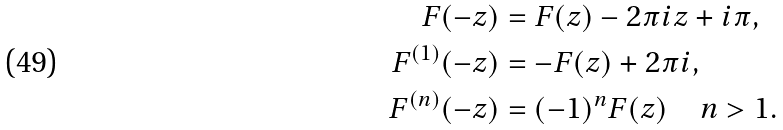<formula> <loc_0><loc_0><loc_500><loc_500>F ( - z ) & = F ( z ) - 2 \pi i z + i \pi , \\ F ^ { ( 1 ) } ( - z ) & = - F ( z ) + 2 \pi i , \\ F ^ { ( n ) } ( - z ) & = ( - 1 ) ^ { n } F ( z ) \quad n > 1 .</formula> 